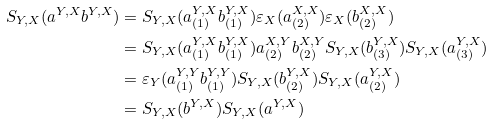<formula> <loc_0><loc_0><loc_500><loc_500>S _ { Y , X } ( a ^ { Y , X } b ^ { Y , X } ) & = S _ { Y , X } ( a _ { ( 1 ) } ^ { Y , X } b _ { ( 1 ) } ^ { Y , X } ) \varepsilon _ { X } ( a _ { ( 2 ) } ^ { X , X } ) \varepsilon _ { X } ( b _ { ( 2 ) } ^ { X , X } ) \\ & = S _ { Y , X } ( a _ { ( 1 ) } ^ { Y , X } b _ { ( 1 ) } ^ { Y , X } ) a _ { ( 2 ) } ^ { X , Y } b _ { ( 2 ) } ^ { X , Y } S _ { Y , X } ( b _ { ( 3 ) } ^ { Y , X } ) S _ { Y , X } ( a _ { ( 3 ) } ^ { Y , X } ) \\ & = \varepsilon _ { Y } ( a _ { ( 1 ) } ^ { Y , Y } b _ { ( 1 ) } ^ { Y , Y } ) S _ { Y , X } ( b _ { ( 2 ) } ^ { Y , X } ) S _ { Y , X } ( a _ { ( 2 ) } ^ { Y , X } ) \\ & = S _ { Y , X } ( b ^ { Y , X } ) S _ { Y , X } ( a ^ { Y , X } )</formula> 